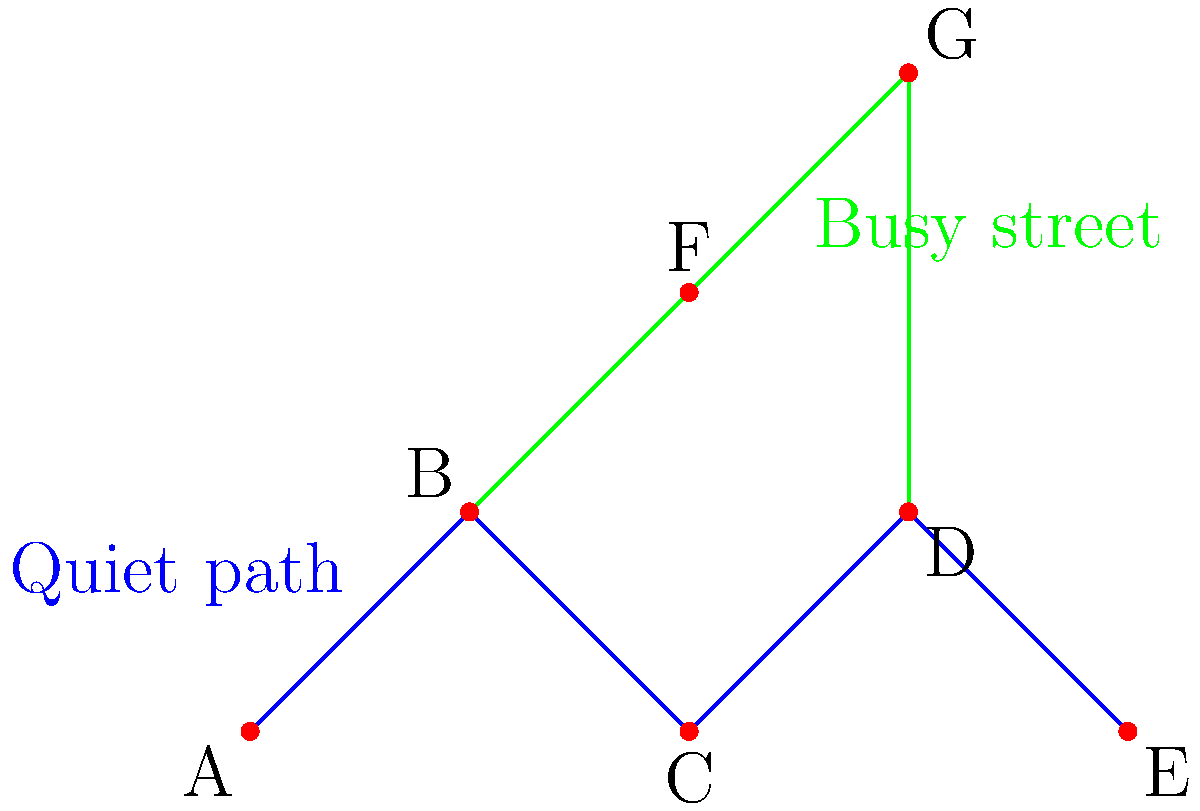In our peaceful harbor town, some residents prefer to avoid the busier streets while walking. The graph above represents walking paths, where blue edges indicate quiet routes and green edges represent busy streets. How many connected components are there in the graph if we only consider the quiet paths (blue edges)? To determine the number of connected components in the graph considering only the quiet paths (blue edges), we need to follow these steps:

1. Identify the vertices: A, B, C, D, and E are connected by blue edges.

2. Ignore the green edges (busy streets): This means we don't consider the connections B-F, F-G, and G-D.

3. Count the connected components:
   - Component 1: A-B-C-D-E (all connected by blue edges)
   - There are no other separate components formed by blue edges

4. Result: There is only one connected component when considering only the quiet paths.

This topology question relates to the persona of a local resident who appreciates peacefulness by focusing on the quiet walking paths and disregarding the busy streets, which might be associated with wealthier areas or more tourist activity.
Answer: 1 